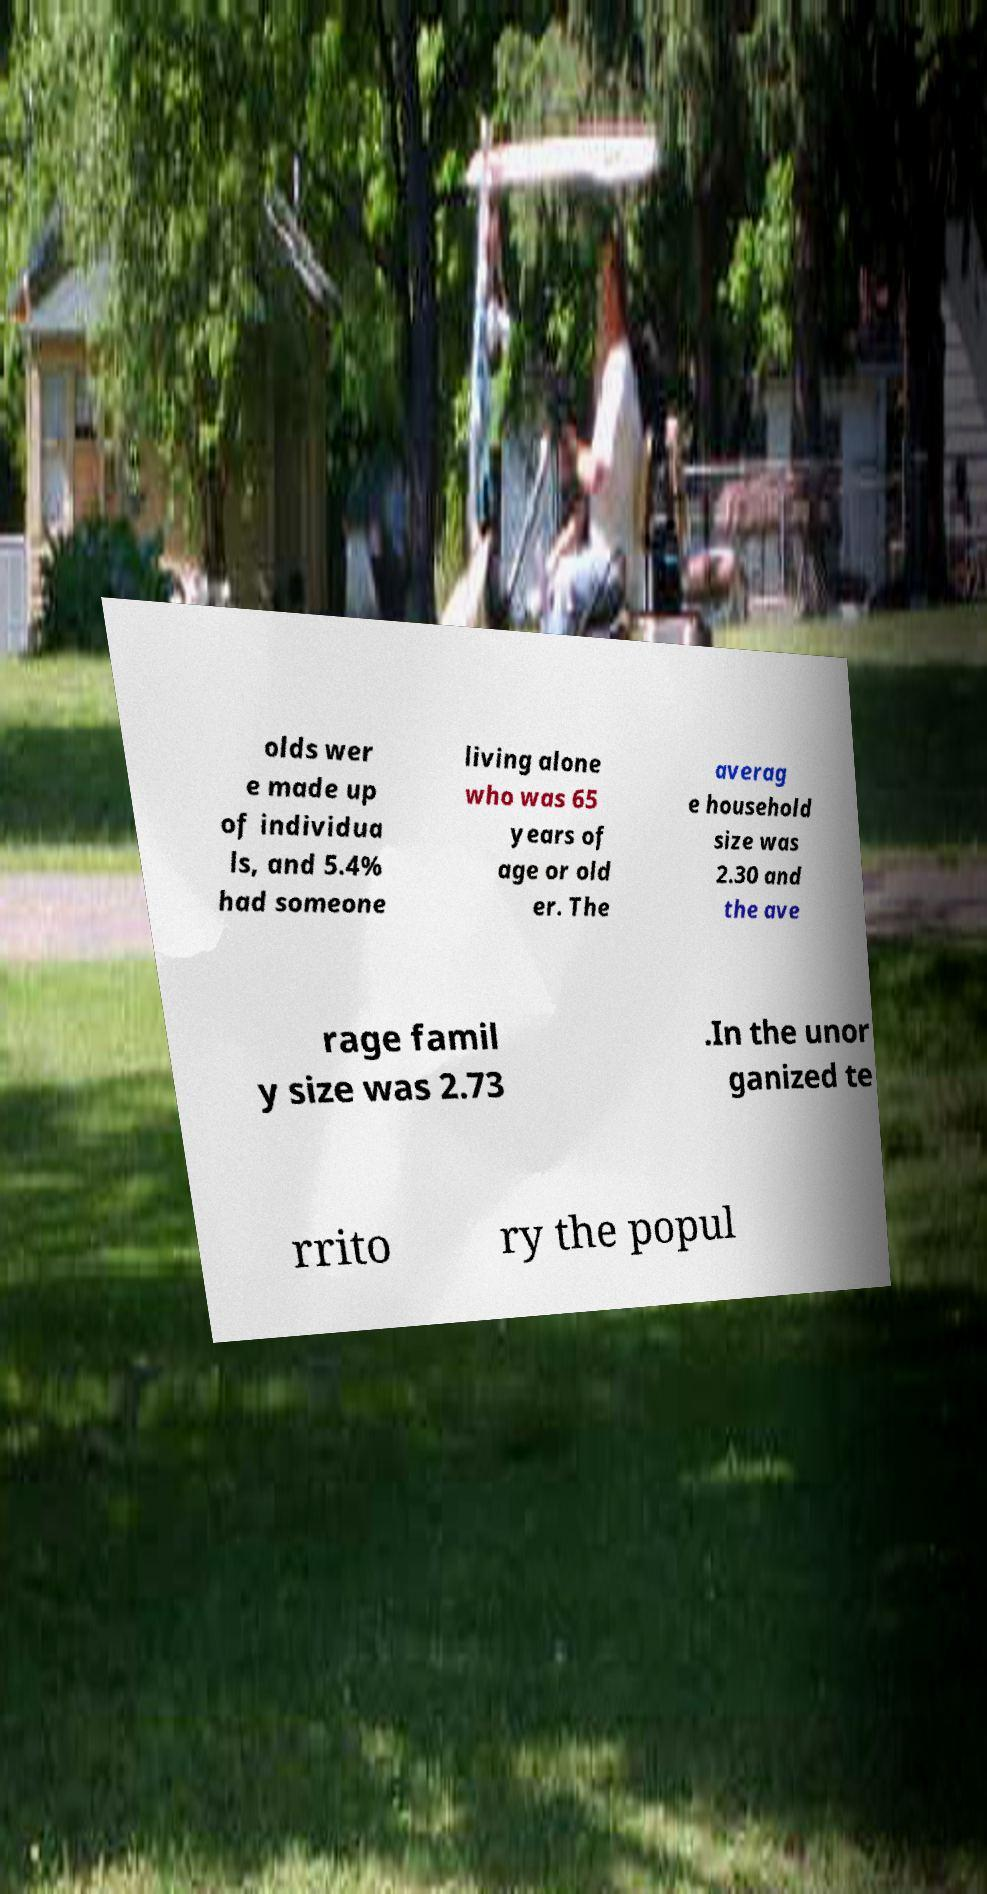Could you assist in decoding the text presented in this image and type it out clearly? olds wer e made up of individua ls, and 5.4% had someone living alone who was 65 years of age or old er. The averag e household size was 2.30 and the ave rage famil y size was 2.73 .In the unor ganized te rrito ry the popul 